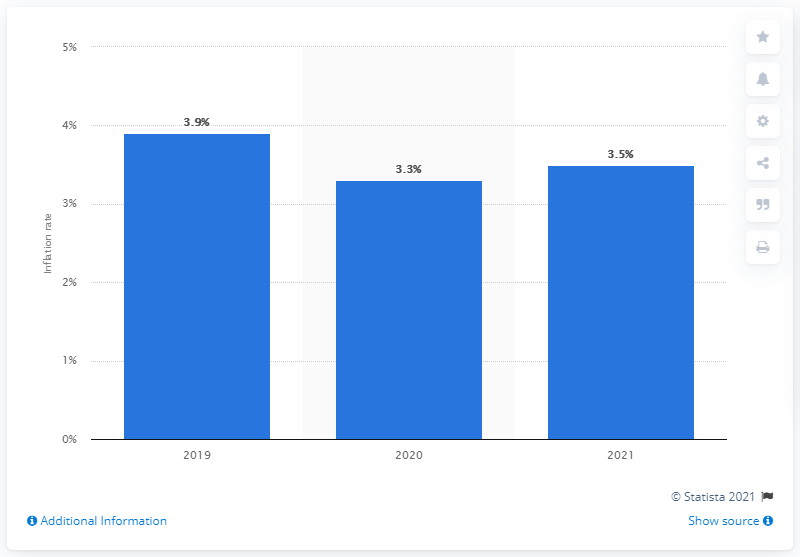Identify some key points in this picture. In 2021, it is projected that inflation will rise from 3.3% to 3.5%. 